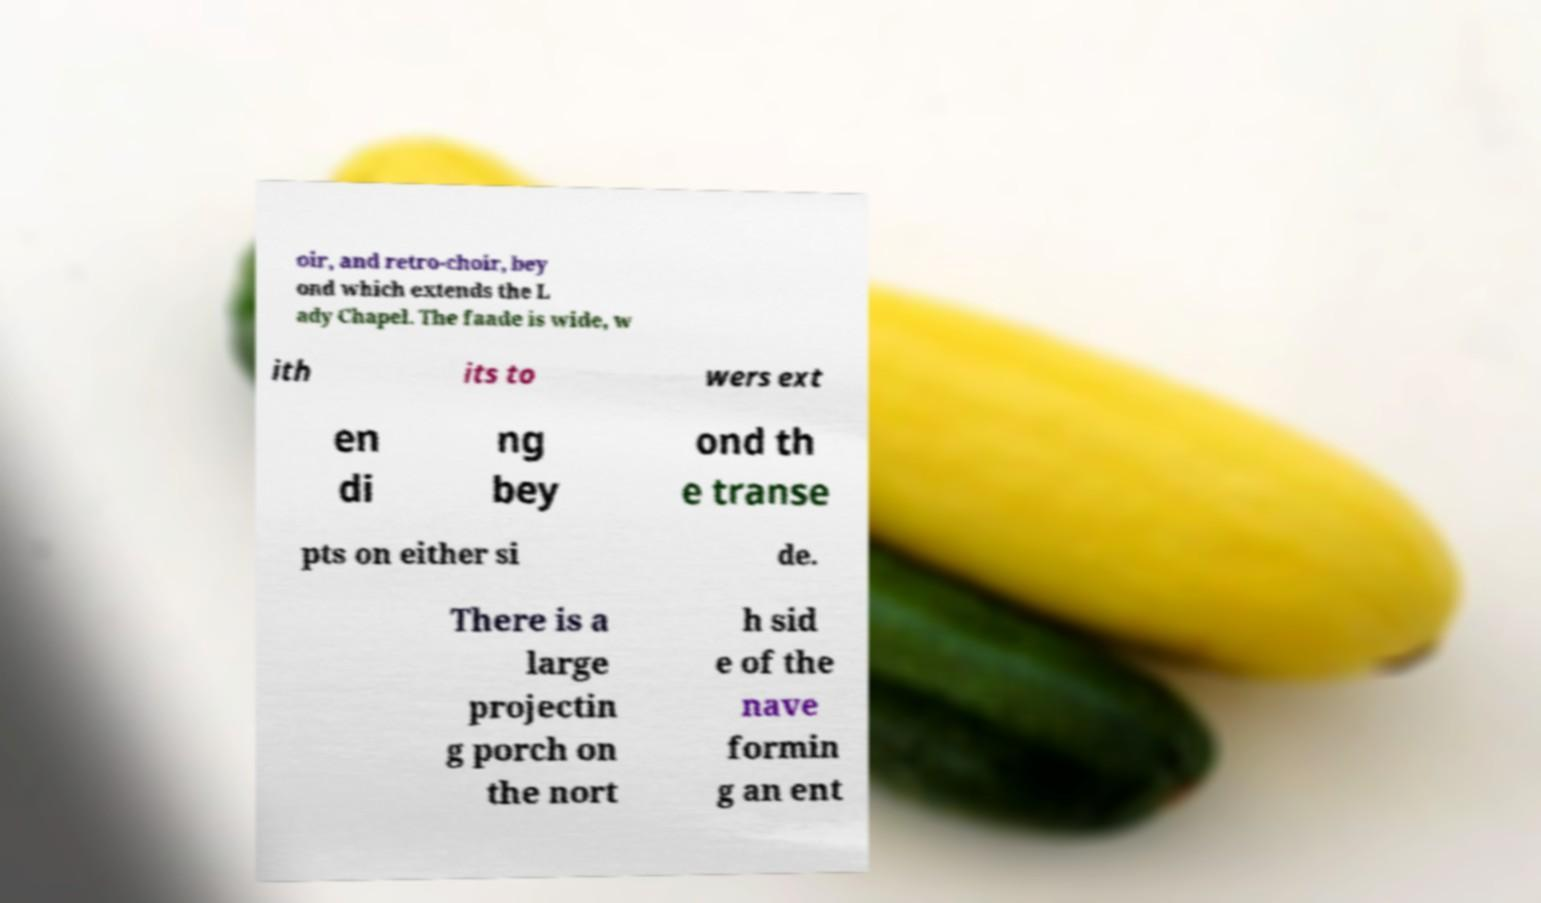Please read and relay the text visible in this image. What does it say? oir, and retro-choir, bey ond which extends the L ady Chapel. The faade is wide, w ith its to wers ext en di ng bey ond th e transe pts on either si de. There is a large projectin g porch on the nort h sid e of the nave formin g an ent 